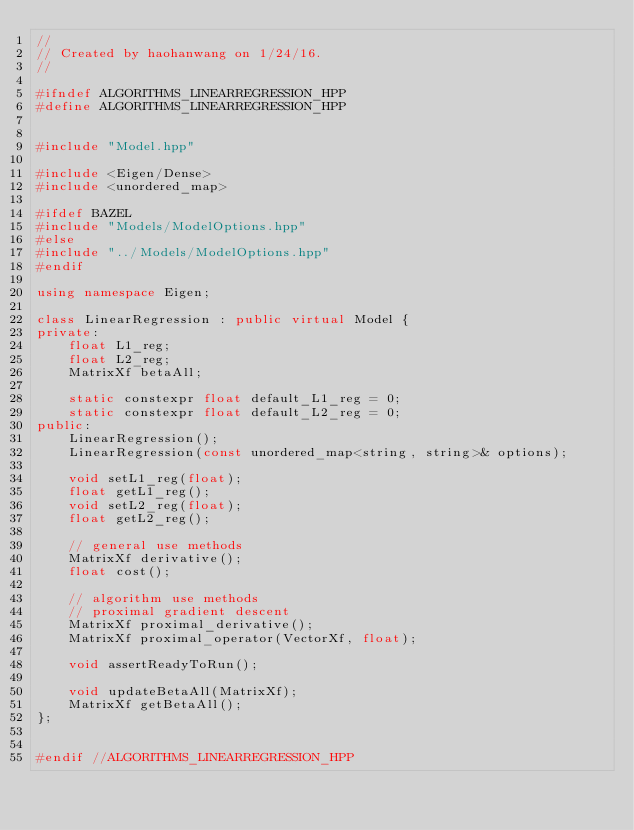<code> <loc_0><loc_0><loc_500><loc_500><_C++_>//
// Created by haohanwang on 1/24/16.
//

#ifndef ALGORITHMS_LINEARREGRESSION_HPP
#define ALGORITHMS_LINEARREGRESSION_HPP


#include "Model.hpp"

#include <Eigen/Dense>
#include <unordered_map>

#ifdef BAZEL
#include "Models/ModelOptions.hpp"
#else
#include "../Models/ModelOptions.hpp"
#endif

using namespace Eigen;

class LinearRegression : public virtual Model {
private:
    float L1_reg;
    float L2_reg;
    MatrixXf betaAll;

    static constexpr float default_L1_reg = 0;
    static constexpr float default_L2_reg = 0;
public:
    LinearRegression();
    LinearRegression(const unordered_map<string, string>& options);

    void setL1_reg(float);
    float getL1_reg();
    void setL2_reg(float);
    float getL2_reg();

    // general use methods
    MatrixXf derivative();
    float cost();

    // algorithm use methods
    // proximal gradient descent
    MatrixXf proximal_derivative();
    MatrixXf proximal_operator(VectorXf, float);

    void assertReadyToRun();

    void updateBetaAll(MatrixXf);
    MatrixXf getBetaAll();
};


#endif //ALGORITHMS_LINEARREGRESSION_HPP
</code> 